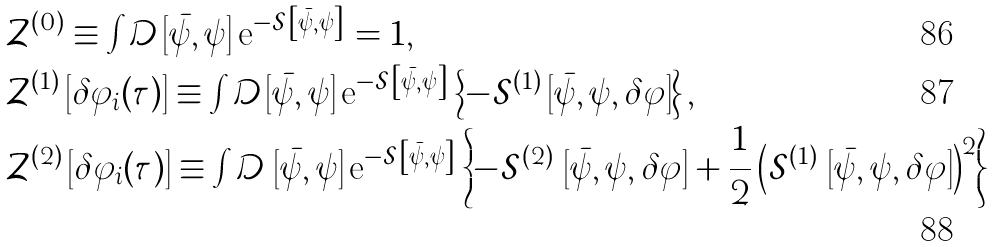Convert formula to latex. <formula><loc_0><loc_0><loc_500><loc_500>& \mathcal { Z } ^ { ( 0 ) } \equiv \int \mathcal { D } \left [ \bar { \psi } , \psi \right ] \text {e} ^ { - \mathcal { S } \left [ \bar { \psi } , \psi \right ] } = 1 , \\ & \mathcal { Z } ^ { ( 1 ) } \left [ \delta \varphi _ { i } ( \tau ) \right ] \equiv \int \mathcal { D } \left [ \bar { \psi } , \psi \right ] \text {e} ^ { - \mathcal { S } \left [ \bar { \psi } , \psi \right ] } \left \{ - \mathcal { S } ^ { ( 1 ) } \left [ \bar { \psi } , \psi , \delta \varphi \right ] \right \} , \\ & \mathcal { Z } ^ { ( 2 ) } \left [ \delta \varphi _ { i } ( \tau ) \right ] \equiv \int \mathcal { D } \, \left [ \bar { \psi } , \psi \right ] \text {e} ^ { - \mathcal { S } \left [ \bar { \psi } , \psi \right ] } \left \{ - \mathcal { S } ^ { ( 2 ) } \, \left [ \bar { \psi } , \psi , \delta \varphi \right ] + \frac { 1 } { 2 } \left ( \mathcal { S } ^ { ( 1 ) } \, \left [ \bar { \psi } , \psi , \delta \varphi \right ] \right ) ^ { 2 } \right \}</formula> 